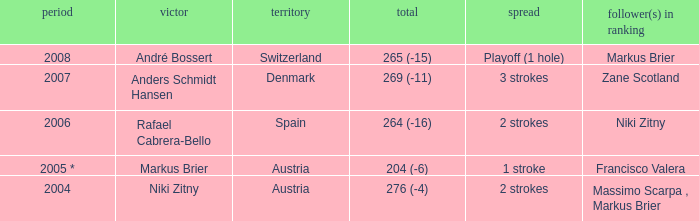Who was the runner-up when the year was 2008? Markus Brier. 